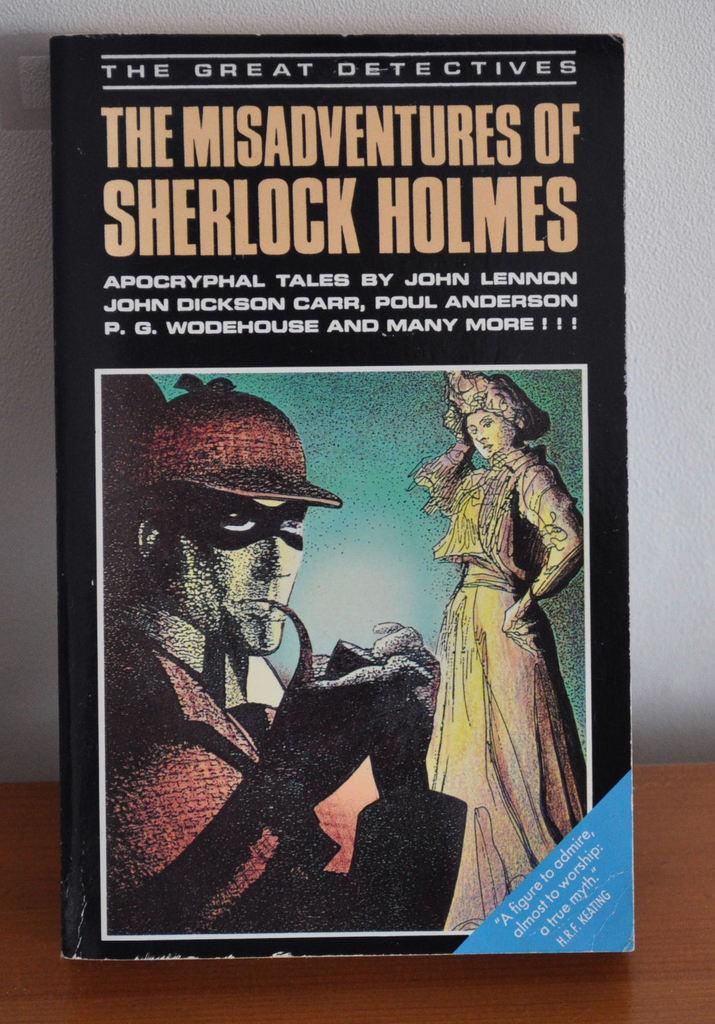Who is the author of the misadventures of sherlock holmes?
Keep it short and to the point. John lennon. What is sherlock's last name?
Your response must be concise. Holmes. 